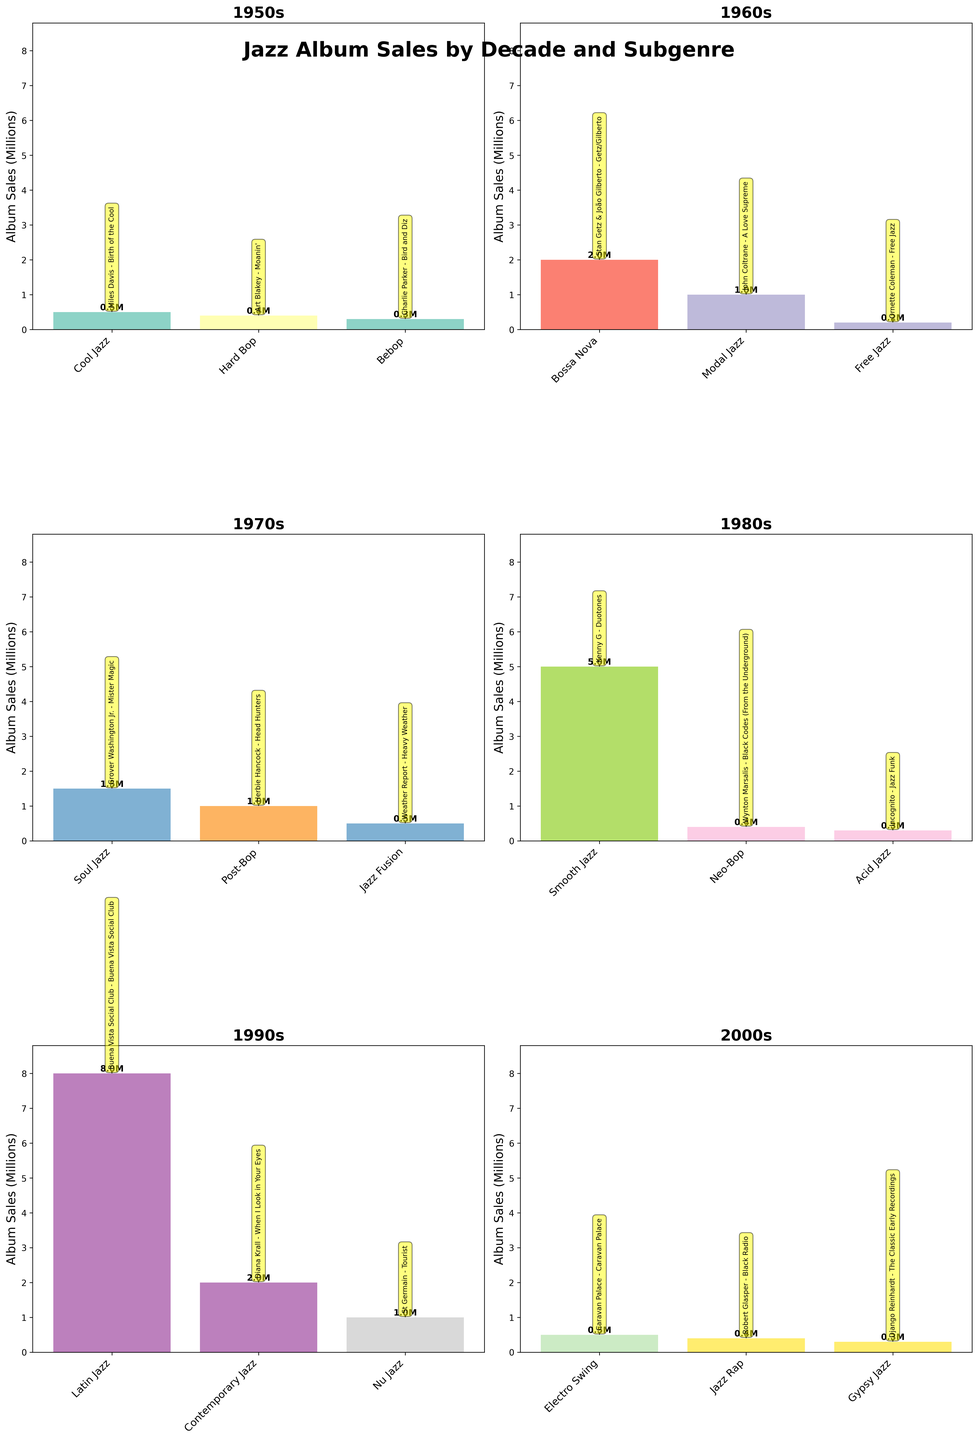What is the total album sales for Cool Jazz in the 1950s? Look at the bar in the subplot for the 1950s corresponding to Cool Jazz. The label on top of the bar shows the sales are 0.5 million.
Answer: 0.5 million Which decade has the highest album sales for Smooth Jazz? Identify the subplot with Smooth Jazz and check the height of its bar. Smooth Jazz bar in the 1980s subplot has the highest album sales at 5 million.
Answer: 1980s How many subgenres are there in the 1960s subplot? Count the number of bars in the 1960s subplot. The 1960s subplot has 3 bars, indicating 3 subgenres.
Answer: 3 What's the difference in sales between Bebop and Hard Bop in the 1950s? Find the heights of the Bebop and Hard Bop bars in the 1950s subplot. Bebop has 0.3 million sales, and Hard Bop has 0.4 million. Subtract 0.3 million from 0.4 million to find the difference.
Answer: 0.1 million Which album in the 1990s had the highest sales, and how much was sold? Look for the tallest bar in the 1990s subplot, which is for Latin Jazz. Hover above it to see the annotation indicating it's "Buena Vista Social Club - Buena Vista Social Club" with 8 million sales.
Answer: Buena Vista Social Club - Buena Vista Social Club, 8 million Compare the total sales for the 1970s and 2000s. Which decade had higher sales? Add the sales figures for all subgenres in both the 1970s and the 2000s. The 1970s have 0.5 million, 1.5 million, and 1 million, totaling 3 million. The 2000s have 0.5 million, 0.4 million, and 0.3 million, totaling 1.2 million. The 1970s had higher sales.
Answer: 1970s Identify the subgenre in the 1960s with the least sales and its album name. In the 1960s subplot, find the shortest bar which is Free Jazz. The annotation shows the album is "Ornette Coleman - Free Jazz" with 0.2 million.
Answer: Free Jazz, Ornette Coleman - Free Jazz What's the average album sales across all decades for the Modal Jazz subgenre? Find the Modal Jazz bar, which is only present in the 1960s. Its sales are 1 million. Since there is only one data point, the average is 1 million.
Answer: 1 million How many albums had sales over 1 million in the 1990s? Look at the heights of all bars in the 1990s subplot and count the bars exceeding 1 million. Only the Latin Jazz bar exceeds 1 million with 8 million sales. Thus, there is just one album.
Answer: 1 